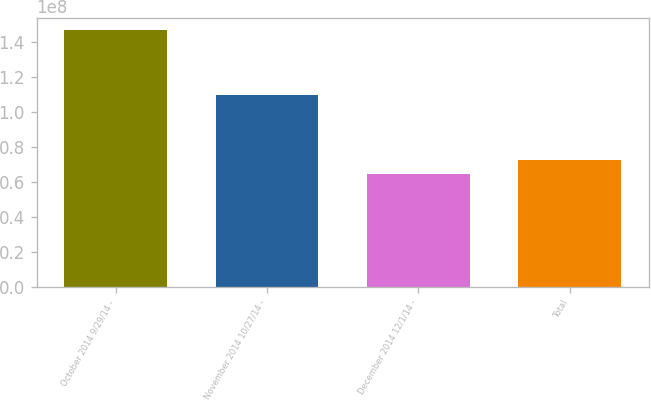Convert chart to OTSL. <chart><loc_0><loc_0><loc_500><loc_500><bar_chart><fcel>October 2014 9/29/14 -<fcel>November 2014 10/27/14 -<fcel>December 2014 12/1/14 -<fcel>Total<nl><fcel>1.46432e+08<fcel>1.0944e+08<fcel>6.41513e+07<fcel>7.23794e+07<nl></chart> 